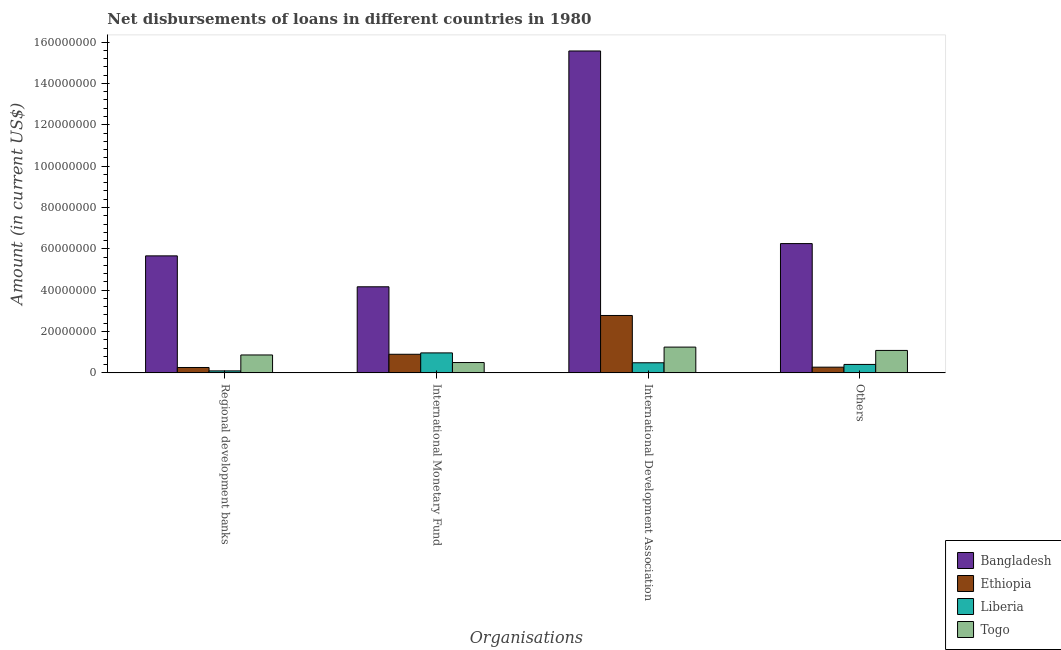How many groups of bars are there?
Offer a very short reply. 4. How many bars are there on the 3rd tick from the left?
Ensure brevity in your answer.  4. How many bars are there on the 2nd tick from the right?
Make the answer very short. 4. What is the label of the 1st group of bars from the left?
Offer a very short reply. Regional development banks. What is the amount of loan disimbursed by other organisations in Liberia?
Offer a terse response. 4.08e+06. Across all countries, what is the maximum amount of loan disimbursed by regional development banks?
Provide a succinct answer. 5.66e+07. Across all countries, what is the minimum amount of loan disimbursed by international development association?
Your answer should be very brief. 4.88e+06. In which country was the amount of loan disimbursed by international development association maximum?
Your answer should be very brief. Bangladesh. In which country was the amount of loan disimbursed by international monetary fund minimum?
Keep it short and to the point. Togo. What is the total amount of loan disimbursed by international development association in the graph?
Offer a very short reply. 2.01e+08. What is the difference between the amount of loan disimbursed by regional development banks in Liberia and that in Bangladesh?
Provide a succinct answer. -5.56e+07. What is the difference between the amount of loan disimbursed by international development association in Togo and the amount of loan disimbursed by regional development banks in Liberia?
Your answer should be compact. 1.15e+07. What is the average amount of loan disimbursed by international monetary fund per country?
Provide a succinct answer. 1.63e+07. What is the difference between the amount of loan disimbursed by other organisations and amount of loan disimbursed by regional development banks in Liberia?
Your answer should be compact. 3.12e+06. What is the ratio of the amount of loan disimbursed by international monetary fund in Togo to that in Bangladesh?
Your answer should be very brief. 0.12. Is the amount of loan disimbursed by other organisations in Liberia less than that in Ethiopia?
Provide a short and direct response. No. Is the difference between the amount of loan disimbursed by international development association in Liberia and Ethiopia greater than the difference between the amount of loan disimbursed by international monetary fund in Liberia and Ethiopia?
Offer a terse response. No. What is the difference between the highest and the second highest amount of loan disimbursed by other organisations?
Ensure brevity in your answer.  5.17e+07. What is the difference between the highest and the lowest amount of loan disimbursed by international monetary fund?
Your answer should be very brief. 3.66e+07. Is it the case that in every country, the sum of the amount of loan disimbursed by regional development banks and amount of loan disimbursed by international development association is greater than the sum of amount of loan disimbursed by other organisations and amount of loan disimbursed by international monetary fund?
Give a very brief answer. No. What does the 3rd bar from the left in Others represents?
Your response must be concise. Liberia. What does the 3rd bar from the right in Regional development banks represents?
Your answer should be very brief. Ethiopia. Is it the case that in every country, the sum of the amount of loan disimbursed by regional development banks and amount of loan disimbursed by international monetary fund is greater than the amount of loan disimbursed by international development association?
Give a very brief answer. No. Are the values on the major ticks of Y-axis written in scientific E-notation?
Make the answer very short. No. How are the legend labels stacked?
Offer a very short reply. Vertical. What is the title of the graph?
Offer a terse response. Net disbursements of loans in different countries in 1980. What is the label or title of the X-axis?
Provide a succinct answer. Organisations. What is the Amount (in current US$) in Bangladesh in Regional development banks?
Provide a short and direct response. 5.66e+07. What is the Amount (in current US$) of Ethiopia in Regional development banks?
Your response must be concise. 2.60e+06. What is the Amount (in current US$) in Liberia in Regional development banks?
Your answer should be very brief. 9.63e+05. What is the Amount (in current US$) of Togo in Regional development banks?
Ensure brevity in your answer.  8.66e+06. What is the Amount (in current US$) in Bangladesh in International Monetary Fund?
Your response must be concise. 4.16e+07. What is the Amount (in current US$) in Ethiopia in International Monetary Fund?
Ensure brevity in your answer.  9.00e+06. What is the Amount (in current US$) of Liberia in International Monetary Fund?
Make the answer very short. 9.66e+06. What is the Amount (in current US$) of Togo in International Monetary Fund?
Your answer should be very brief. 5.00e+06. What is the Amount (in current US$) of Bangladesh in International Development Association?
Your response must be concise. 1.56e+08. What is the Amount (in current US$) in Ethiopia in International Development Association?
Offer a terse response. 2.78e+07. What is the Amount (in current US$) of Liberia in International Development Association?
Offer a terse response. 4.88e+06. What is the Amount (in current US$) in Togo in International Development Association?
Make the answer very short. 1.25e+07. What is the Amount (in current US$) in Bangladesh in Others?
Your answer should be compact. 6.25e+07. What is the Amount (in current US$) of Ethiopia in Others?
Ensure brevity in your answer.  2.76e+06. What is the Amount (in current US$) of Liberia in Others?
Offer a very short reply. 4.08e+06. What is the Amount (in current US$) in Togo in Others?
Provide a short and direct response. 1.09e+07. Across all Organisations, what is the maximum Amount (in current US$) of Bangladesh?
Provide a succinct answer. 1.56e+08. Across all Organisations, what is the maximum Amount (in current US$) in Ethiopia?
Your answer should be very brief. 2.78e+07. Across all Organisations, what is the maximum Amount (in current US$) in Liberia?
Your answer should be very brief. 9.66e+06. Across all Organisations, what is the maximum Amount (in current US$) of Togo?
Keep it short and to the point. 1.25e+07. Across all Organisations, what is the minimum Amount (in current US$) in Bangladesh?
Make the answer very short. 4.16e+07. Across all Organisations, what is the minimum Amount (in current US$) in Ethiopia?
Provide a short and direct response. 2.60e+06. Across all Organisations, what is the minimum Amount (in current US$) in Liberia?
Offer a very short reply. 9.63e+05. Across all Organisations, what is the minimum Amount (in current US$) in Togo?
Provide a short and direct response. 5.00e+06. What is the total Amount (in current US$) of Bangladesh in the graph?
Provide a succinct answer. 3.16e+08. What is the total Amount (in current US$) of Ethiopia in the graph?
Give a very brief answer. 4.21e+07. What is the total Amount (in current US$) of Liberia in the graph?
Make the answer very short. 1.96e+07. What is the total Amount (in current US$) in Togo in the graph?
Make the answer very short. 3.70e+07. What is the difference between the Amount (in current US$) in Bangladesh in Regional development banks and that in International Monetary Fund?
Your answer should be very brief. 1.50e+07. What is the difference between the Amount (in current US$) of Ethiopia in Regional development banks and that in International Monetary Fund?
Make the answer very short. -6.40e+06. What is the difference between the Amount (in current US$) of Liberia in Regional development banks and that in International Monetary Fund?
Your answer should be compact. -8.70e+06. What is the difference between the Amount (in current US$) of Togo in Regional development banks and that in International Monetary Fund?
Ensure brevity in your answer.  3.66e+06. What is the difference between the Amount (in current US$) in Bangladesh in Regional development banks and that in International Development Association?
Make the answer very short. -9.91e+07. What is the difference between the Amount (in current US$) in Ethiopia in Regional development banks and that in International Development Association?
Your answer should be compact. -2.52e+07. What is the difference between the Amount (in current US$) in Liberia in Regional development banks and that in International Development Association?
Your response must be concise. -3.92e+06. What is the difference between the Amount (in current US$) in Togo in Regional development banks and that in International Development Association?
Your response must be concise. -3.81e+06. What is the difference between the Amount (in current US$) in Bangladesh in Regional development banks and that in Others?
Ensure brevity in your answer.  -5.94e+06. What is the difference between the Amount (in current US$) of Ethiopia in Regional development banks and that in Others?
Your answer should be very brief. -1.58e+05. What is the difference between the Amount (in current US$) of Liberia in Regional development banks and that in Others?
Your response must be concise. -3.12e+06. What is the difference between the Amount (in current US$) in Togo in Regional development banks and that in Others?
Offer a terse response. -2.19e+06. What is the difference between the Amount (in current US$) in Bangladesh in International Monetary Fund and that in International Development Association?
Ensure brevity in your answer.  -1.14e+08. What is the difference between the Amount (in current US$) in Ethiopia in International Monetary Fund and that in International Development Association?
Keep it short and to the point. -1.88e+07. What is the difference between the Amount (in current US$) in Liberia in International Monetary Fund and that in International Development Association?
Ensure brevity in your answer.  4.78e+06. What is the difference between the Amount (in current US$) of Togo in International Monetary Fund and that in International Development Association?
Offer a terse response. -7.47e+06. What is the difference between the Amount (in current US$) of Bangladesh in International Monetary Fund and that in Others?
Provide a short and direct response. -2.09e+07. What is the difference between the Amount (in current US$) in Ethiopia in International Monetary Fund and that in Others?
Make the answer very short. 6.24e+06. What is the difference between the Amount (in current US$) of Liberia in International Monetary Fund and that in Others?
Ensure brevity in your answer.  5.58e+06. What is the difference between the Amount (in current US$) of Togo in International Monetary Fund and that in Others?
Make the answer very short. -5.85e+06. What is the difference between the Amount (in current US$) of Bangladesh in International Development Association and that in Others?
Your answer should be compact. 9.32e+07. What is the difference between the Amount (in current US$) of Ethiopia in International Development Association and that in Others?
Give a very brief answer. 2.50e+07. What is the difference between the Amount (in current US$) of Liberia in International Development Association and that in Others?
Your response must be concise. 8.04e+05. What is the difference between the Amount (in current US$) in Togo in International Development Association and that in Others?
Ensure brevity in your answer.  1.61e+06. What is the difference between the Amount (in current US$) in Bangladesh in Regional development banks and the Amount (in current US$) in Ethiopia in International Monetary Fund?
Your answer should be very brief. 4.76e+07. What is the difference between the Amount (in current US$) in Bangladesh in Regional development banks and the Amount (in current US$) in Liberia in International Monetary Fund?
Your answer should be very brief. 4.69e+07. What is the difference between the Amount (in current US$) in Bangladesh in Regional development banks and the Amount (in current US$) in Togo in International Monetary Fund?
Give a very brief answer. 5.16e+07. What is the difference between the Amount (in current US$) of Ethiopia in Regional development banks and the Amount (in current US$) of Liberia in International Monetary Fund?
Offer a terse response. -7.06e+06. What is the difference between the Amount (in current US$) in Ethiopia in Regional development banks and the Amount (in current US$) in Togo in International Monetary Fund?
Offer a terse response. -2.40e+06. What is the difference between the Amount (in current US$) in Liberia in Regional development banks and the Amount (in current US$) in Togo in International Monetary Fund?
Offer a terse response. -4.04e+06. What is the difference between the Amount (in current US$) of Bangladesh in Regional development banks and the Amount (in current US$) of Ethiopia in International Development Association?
Your answer should be compact. 2.88e+07. What is the difference between the Amount (in current US$) in Bangladesh in Regional development banks and the Amount (in current US$) in Liberia in International Development Association?
Keep it short and to the point. 5.17e+07. What is the difference between the Amount (in current US$) of Bangladesh in Regional development banks and the Amount (in current US$) of Togo in International Development Association?
Your answer should be very brief. 4.41e+07. What is the difference between the Amount (in current US$) of Ethiopia in Regional development banks and the Amount (in current US$) of Liberia in International Development Association?
Provide a short and direct response. -2.28e+06. What is the difference between the Amount (in current US$) of Ethiopia in Regional development banks and the Amount (in current US$) of Togo in International Development Association?
Your answer should be very brief. -9.87e+06. What is the difference between the Amount (in current US$) of Liberia in Regional development banks and the Amount (in current US$) of Togo in International Development Association?
Offer a very short reply. -1.15e+07. What is the difference between the Amount (in current US$) in Bangladesh in Regional development banks and the Amount (in current US$) in Ethiopia in Others?
Keep it short and to the point. 5.38e+07. What is the difference between the Amount (in current US$) of Bangladesh in Regional development banks and the Amount (in current US$) of Liberia in Others?
Your answer should be very brief. 5.25e+07. What is the difference between the Amount (in current US$) of Bangladesh in Regional development banks and the Amount (in current US$) of Togo in Others?
Your answer should be compact. 4.57e+07. What is the difference between the Amount (in current US$) in Ethiopia in Regional development banks and the Amount (in current US$) in Liberia in Others?
Ensure brevity in your answer.  -1.48e+06. What is the difference between the Amount (in current US$) in Ethiopia in Regional development banks and the Amount (in current US$) in Togo in Others?
Offer a very short reply. -8.25e+06. What is the difference between the Amount (in current US$) of Liberia in Regional development banks and the Amount (in current US$) of Togo in Others?
Give a very brief answer. -9.89e+06. What is the difference between the Amount (in current US$) in Bangladesh in International Monetary Fund and the Amount (in current US$) in Ethiopia in International Development Association?
Provide a short and direct response. 1.39e+07. What is the difference between the Amount (in current US$) in Bangladesh in International Monetary Fund and the Amount (in current US$) in Liberia in International Development Association?
Offer a terse response. 3.68e+07. What is the difference between the Amount (in current US$) of Bangladesh in International Monetary Fund and the Amount (in current US$) of Togo in International Development Association?
Your response must be concise. 2.92e+07. What is the difference between the Amount (in current US$) of Ethiopia in International Monetary Fund and the Amount (in current US$) of Liberia in International Development Association?
Provide a succinct answer. 4.11e+06. What is the difference between the Amount (in current US$) in Ethiopia in International Monetary Fund and the Amount (in current US$) in Togo in International Development Association?
Provide a succinct answer. -3.47e+06. What is the difference between the Amount (in current US$) in Liberia in International Monetary Fund and the Amount (in current US$) in Togo in International Development Association?
Your response must be concise. -2.80e+06. What is the difference between the Amount (in current US$) of Bangladesh in International Monetary Fund and the Amount (in current US$) of Ethiopia in Others?
Offer a very short reply. 3.89e+07. What is the difference between the Amount (in current US$) of Bangladesh in International Monetary Fund and the Amount (in current US$) of Liberia in Others?
Your answer should be very brief. 3.76e+07. What is the difference between the Amount (in current US$) in Bangladesh in International Monetary Fund and the Amount (in current US$) in Togo in Others?
Your answer should be compact. 3.08e+07. What is the difference between the Amount (in current US$) in Ethiopia in International Monetary Fund and the Amount (in current US$) in Liberia in Others?
Offer a terse response. 4.92e+06. What is the difference between the Amount (in current US$) in Ethiopia in International Monetary Fund and the Amount (in current US$) in Togo in Others?
Provide a short and direct response. -1.86e+06. What is the difference between the Amount (in current US$) of Liberia in International Monetary Fund and the Amount (in current US$) of Togo in Others?
Keep it short and to the point. -1.19e+06. What is the difference between the Amount (in current US$) of Bangladesh in International Development Association and the Amount (in current US$) of Ethiopia in Others?
Provide a succinct answer. 1.53e+08. What is the difference between the Amount (in current US$) of Bangladesh in International Development Association and the Amount (in current US$) of Liberia in Others?
Your answer should be very brief. 1.52e+08. What is the difference between the Amount (in current US$) of Bangladesh in International Development Association and the Amount (in current US$) of Togo in Others?
Make the answer very short. 1.45e+08. What is the difference between the Amount (in current US$) in Ethiopia in International Development Association and the Amount (in current US$) in Liberia in Others?
Make the answer very short. 2.37e+07. What is the difference between the Amount (in current US$) of Ethiopia in International Development Association and the Amount (in current US$) of Togo in Others?
Your answer should be compact. 1.69e+07. What is the difference between the Amount (in current US$) of Liberia in International Development Association and the Amount (in current US$) of Togo in Others?
Make the answer very short. -5.97e+06. What is the average Amount (in current US$) of Bangladesh per Organisations?
Your answer should be compact. 7.91e+07. What is the average Amount (in current US$) in Ethiopia per Organisations?
Your answer should be very brief. 1.05e+07. What is the average Amount (in current US$) of Liberia per Organisations?
Keep it short and to the point. 4.90e+06. What is the average Amount (in current US$) in Togo per Organisations?
Provide a succinct answer. 9.24e+06. What is the difference between the Amount (in current US$) of Bangladesh and Amount (in current US$) of Ethiopia in Regional development banks?
Ensure brevity in your answer.  5.40e+07. What is the difference between the Amount (in current US$) of Bangladesh and Amount (in current US$) of Liberia in Regional development banks?
Keep it short and to the point. 5.56e+07. What is the difference between the Amount (in current US$) of Bangladesh and Amount (in current US$) of Togo in Regional development banks?
Your answer should be compact. 4.79e+07. What is the difference between the Amount (in current US$) of Ethiopia and Amount (in current US$) of Liberia in Regional development banks?
Offer a terse response. 1.64e+06. What is the difference between the Amount (in current US$) in Ethiopia and Amount (in current US$) in Togo in Regional development banks?
Ensure brevity in your answer.  -6.06e+06. What is the difference between the Amount (in current US$) in Liberia and Amount (in current US$) in Togo in Regional development banks?
Your response must be concise. -7.70e+06. What is the difference between the Amount (in current US$) in Bangladesh and Amount (in current US$) in Ethiopia in International Monetary Fund?
Provide a succinct answer. 3.26e+07. What is the difference between the Amount (in current US$) of Bangladesh and Amount (in current US$) of Liberia in International Monetary Fund?
Provide a succinct answer. 3.20e+07. What is the difference between the Amount (in current US$) of Bangladesh and Amount (in current US$) of Togo in International Monetary Fund?
Your answer should be compact. 3.66e+07. What is the difference between the Amount (in current US$) in Ethiopia and Amount (in current US$) in Liberia in International Monetary Fund?
Provide a short and direct response. -6.66e+05. What is the difference between the Amount (in current US$) of Ethiopia and Amount (in current US$) of Togo in International Monetary Fund?
Keep it short and to the point. 4.00e+06. What is the difference between the Amount (in current US$) of Liberia and Amount (in current US$) of Togo in International Monetary Fund?
Provide a succinct answer. 4.66e+06. What is the difference between the Amount (in current US$) in Bangladesh and Amount (in current US$) in Ethiopia in International Development Association?
Your response must be concise. 1.28e+08. What is the difference between the Amount (in current US$) of Bangladesh and Amount (in current US$) of Liberia in International Development Association?
Provide a succinct answer. 1.51e+08. What is the difference between the Amount (in current US$) of Bangladesh and Amount (in current US$) of Togo in International Development Association?
Your answer should be very brief. 1.43e+08. What is the difference between the Amount (in current US$) in Ethiopia and Amount (in current US$) in Liberia in International Development Association?
Provide a short and direct response. 2.29e+07. What is the difference between the Amount (in current US$) of Ethiopia and Amount (in current US$) of Togo in International Development Association?
Make the answer very short. 1.53e+07. What is the difference between the Amount (in current US$) of Liberia and Amount (in current US$) of Togo in International Development Association?
Offer a terse response. -7.58e+06. What is the difference between the Amount (in current US$) of Bangladesh and Amount (in current US$) of Ethiopia in Others?
Keep it short and to the point. 5.98e+07. What is the difference between the Amount (in current US$) of Bangladesh and Amount (in current US$) of Liberia in Others?
Your answer should be very brief. 5.85e+07. What is the difference between the Amount (in current US$) in Bangladesh and Amount (in current US$) in Togo in Others?
Keep it short and to the point. 5.17e+07. What is the difference between the Amount (in current US$) in Ethiopia and Amount (in current US$) in Liberia in Others?
Provide a short and direct response. -1.32e+06. What is the difference between the Amount (in current US$) in Ethiopia and Amount (in current US$) in Togo in Others?
Give a very brief answer. -8.09e+06. What is the difference between the Amount (in current US$) in Liberia and Amount (in current US$) in Togo in Others?
Your answer should be very brief. -6.77e+06. What is the ratio of the Amount (in current US$) in Bangladesh in Regional development banks to that in International Monetary Fund?
Your response must be concise. 1.36. What is the ratio of the Amount (in current US$) of Ethiopia in Regional development banks to that in International Monetary Fund?
Your answer should be compact. 0.29. What is the ratio of the Amount (in current US$) of Liberia in Regional development banks to that in International Monetary Fund?
Your answer should be very brief. 0.1. What is the ratio of the Amount (in current US$) of Togo in Regional development banks to that in International Monetary Fund?
Provide a succinct answer. 1.73. What is the ratio of the Amount (in current US$) of Bangladesh in Regional development banks to that in International Development Association?
Offer a terse response. 0.36. What is the ratio of the Amount (in current US$) in Ethiopia in Regional development banks to that in International Development Association?
Keep it short and to the point. 0.09. What is the ratio of the Amount (in current US$) of Liberia in Regional development banks to that in International Development Association?
Provide a succinct answer. 0.2. What is the ratio of the Amount (in current US$) of Togo in Regional development banks to that in International Development Association?
Keep it short and to the point. 0.69. What is the ratio of the Amount (in current US$) in Bangladesh in Regional development banks to that in Others?
Offer a terse response. 0.9. What is the ratio of the Amount (in current US$) of Ethiopia in Regional development banks to that in Others?
Your response must be concise. 0.94. What is the ratio of the Amount (in current US$) of Liberia in Regional development banks to that in Others?
Provide a short and direct response. 0.24. What is the ratio of the Amount (in current US$) in Togo in Regional development banks to that in Others?
Make the answer very short. 0.8. What is the ratio of the Amount (in current US$) of Bangladesh in International Monetary Fund to that in International Development Association?
Give a very brief answer. 0.27. What is the ratio of the Amount (in current US$) in Ethiopia in International Monetary Fund to that in International Development Association?
Your response must be concise. 0.32. What is the ratio of the Amount (in current US$) of Liberia in International Monetary Fund to that in International Development Association?
Offer a terse response. 1.98. What is the ratio of the Amount (in current US$) of Togo in International Monetary Fund to that in International Development Association?
Your answer should be compact. 0.4. What is the ratio of the Amount (in current US$) in Bangladesh in International Monetary Fund to that in Others?
Keep it short and to the point. 0.67. What is the ratio of the Amount (in current US$) of Ethiopia in International Monetary Fund to that in Others?
Keep it short and to the point. 3.26. What is the ratio of the Amount (in current US$) in Liberia in International Monetary Fund to that in Others?
Your response must be concise. 2.37. What is the ratio of the Amount (in current US$) in Togo in International Monetary Fund to that in Others?
Ensure brevity in your answer.  0.46. What is the ratio of the Amount (in current US$) of Bangladesh in International Development Association to that in Others?
Your answer should be very brief. 2.49. What is the ratio of the Amount (in current US$) of Ethiopia in International Development Association to that in Others?
Provide a short and direct response. 10.07. What is the ratio of the Amount (in current US$) in Liberia in International Development Association to that in Others?
Your answer should be compact. 1.2. What is the ratio of the Amount (in current US$) of Togo in International Development Association to that in Others?
Make the answer very short. 1.15. What is the difference between the highest and the second highest Amount (in current US$) in Bangladesh?
Your response must be concise. 9.32e+07. What is the difference between the highest and the second highest Amount (in current US$) in Ethiopia?
Your answer should be compact. 1.88e+07. What is the difference between the highest and the second highest Amount (in current US$) of Liberia?
Keep it short and to the point. 4.78e+06. What is the difference between the highest and the second highest Amount (in current US$) of Togo?
Ensure brevity in your answer.  1.61e+06. What is the difference between the highest and the lowest Amount (in current US$) in Bangladesh?
Provide a short and direct response. 1.14e+08. What is the difference between the highest and the lowest Amount (in current US$) of Ethiopia?
Keep it short and to the point. 2.52e+07. What is the difference between the highest and the lowest Amount (in current US$) of Liberia?
Offer a terse response. 8.70e+06. What is the difference between the highest and the lowest Amount (in current US$) in Togo?
Offer a terse response. 7.47e+06. 